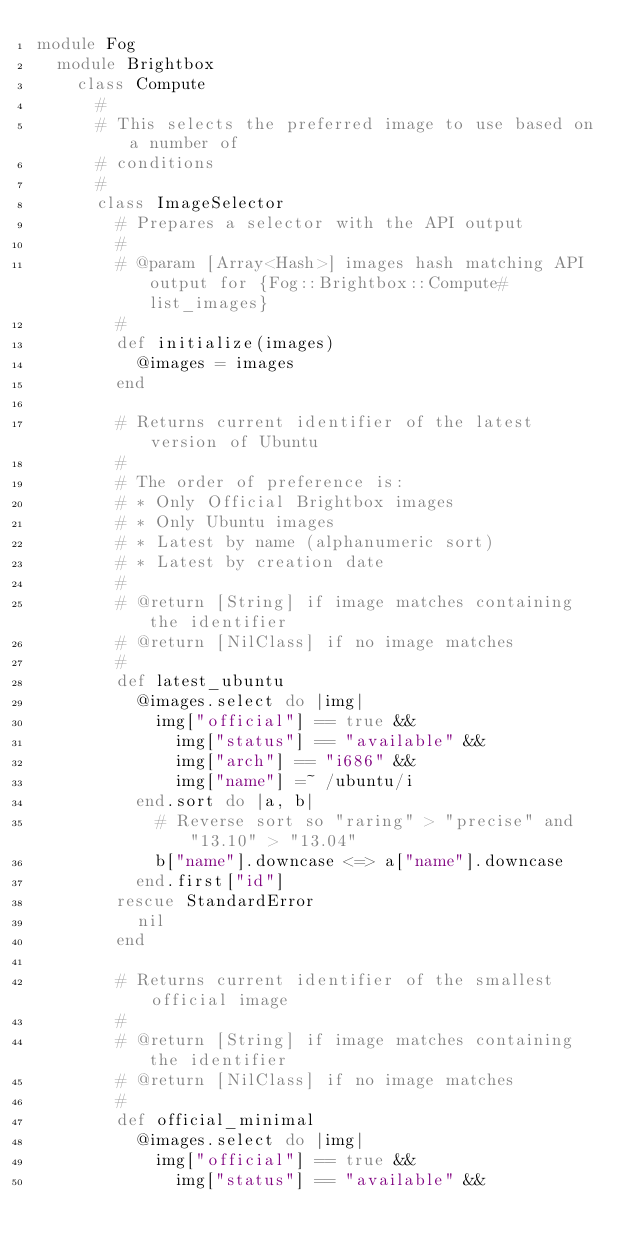<code> <loc_0><loc_0><loc_500><loc_500><_Ruby_>module Fog
  module Brightbox
    class Compute
      #
      # This selects the preferred image to use based on a number of
      # conditions
      #
      class ImageSelector
        # Prepares a selector with the API output
        #
        # @param [Array<Hash>] images hash matching API output for {Fog::Brightbox::Compute#list_images}
        #
        def initialize(images)
          @images = images
        end

        # Returns current identifier of the latest version of Ubuntu
        #
        # The order of preference is:
        # * Only Official Brightbox images
        # * Only Ubuntu images
        # * Latest by name (alphanumeric sort)
        # * Latest by creation date
        #
        # @return [String] if image matches containing the identifier
        # @return [NilClass] if no image matches
        #
        def latest_ubuntu
          @images.select do |img|
            img["official"] == true &&
              img["status"] == "available" &&
              img["arch"] == "i686" &&
              img["name"] =~ /ubuntu/i
          end.sort do |a, b|
            # Reverse sort so "raring" > "precise" and "13.10" > "13.04"
            b["name"].downcase <=> a["name"].downcase
          end.first["id"]
        rescue StandardError
          nil
        end

        # Returns current identifier of the smallest official image
        #
        # @return [String] if image matches containing the identifier
        # @return [NilClass] if no image matches
        #
        def official_minimal
          @images.select do |img|
            img["official"] == true &&
              img["status"] == "available" &&</code> 